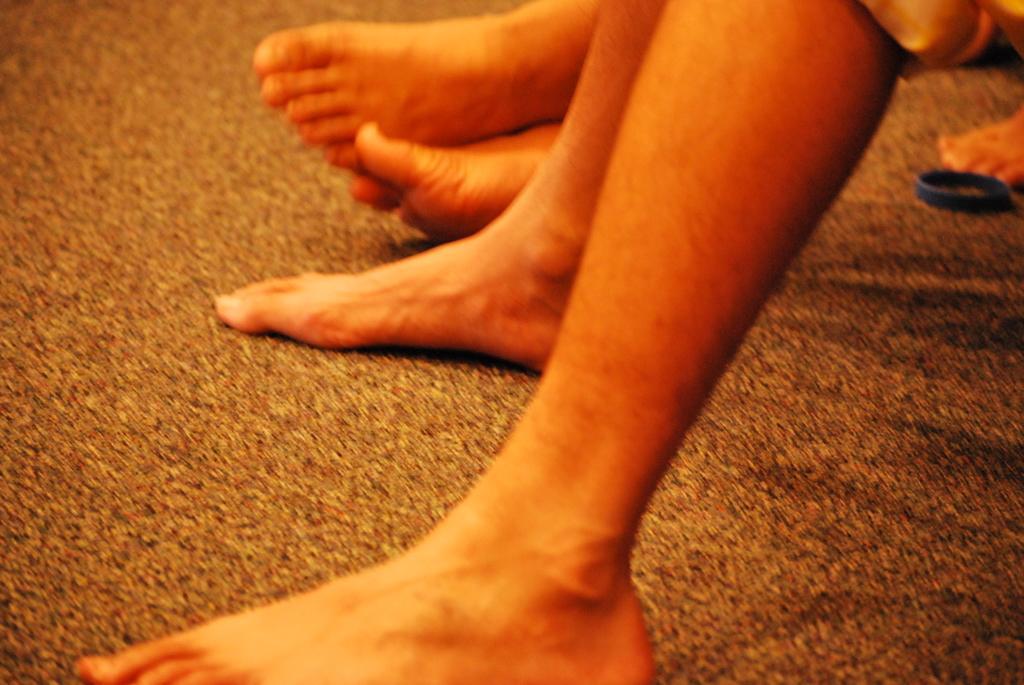Describe this image in one or two sentences. In this picture we can see legs of three persons, on the right side there is a ring. 